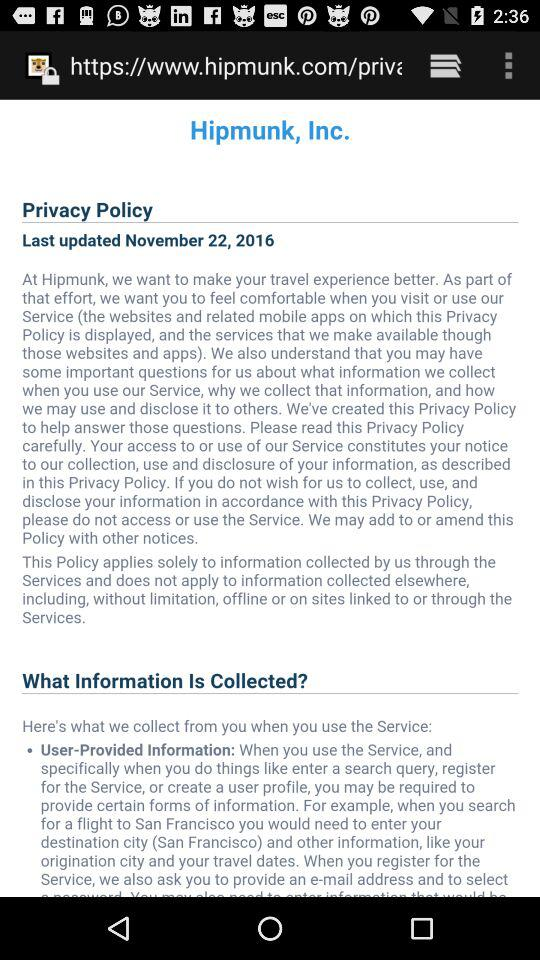What is the updated date of the policy? The date is November 22, 2016. 